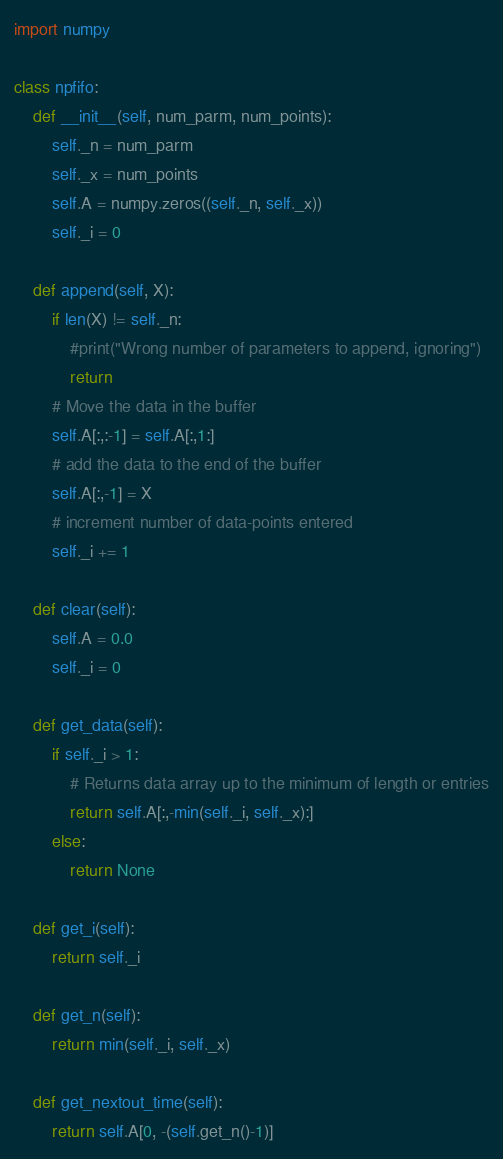Convert code to text. <code><loc_0><loc_0><loc_500><loc_500><_Python_>import numpy

class npfifo:
    def __init__(self, num_parm, num_points):
        self._n = num_parm
        self._x = num_points
        self.A = numpy.zeros((self._n, self._x))
        self._i = 0

    def append(self, X):
        if len(X) != self._n:
            #print("Wrong number of parameters to append, ignoring")
            return
        # Move the data in the buffer
        self.A[:,:-1] = self.A[:,1:]
        # add the data to the end of the buffer
        self.A[:,-1] = X
        # increment number of data-points entered
        self._i += 1

    def clear(self):
        self.A = 0.0
        self._i = 0

    def get_data(self):
        if self._i > 1:
            # Returns data array up to the minimum of length or entries
            return self.A[:,-min(self._i, self._x):]
        else:
            return None

    def get_i(self):
        return self._i

    def get_n(self):
        return min(self._i, self._x)

    def get_nextout_time(self):
        return self.A[0, -(self.get_n()-1)]
</code> 